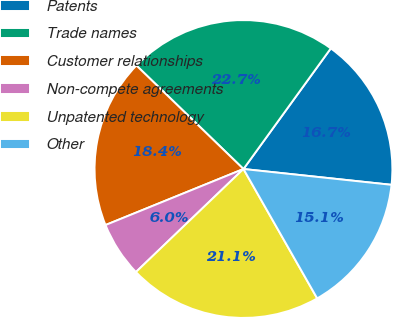<chart> <loc_0><loc_0><loc_500><loc_500><pie_chart><fcel>Patents<fcel>Trade names<fcel>Customer relationships<fcel>Non-compete agreements<fcel>Unpatented technology<fcel>Other<nl><fcel>16.72%<fcel>22.74%<fcel>18.37%<fcel>6.02%<fcel>21.08%<fcel>15.06%<nl></chart> 